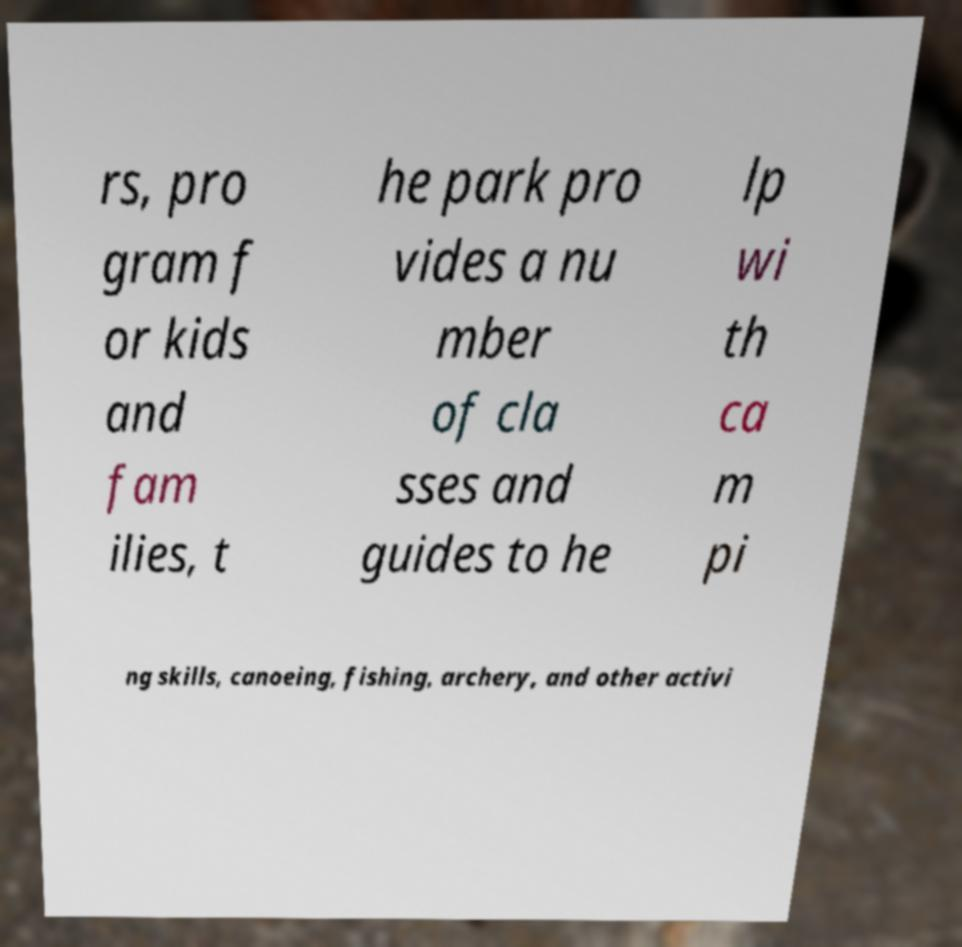Could you assist in decoding the text presented in this image and type it out clearly? rs, pro gram f or kids and fam ilies, t he park pro vides a nu mber of cla sses and guides to he lp wi th ca m pi ng skills, canoeing, fishing, archery, and other activi 